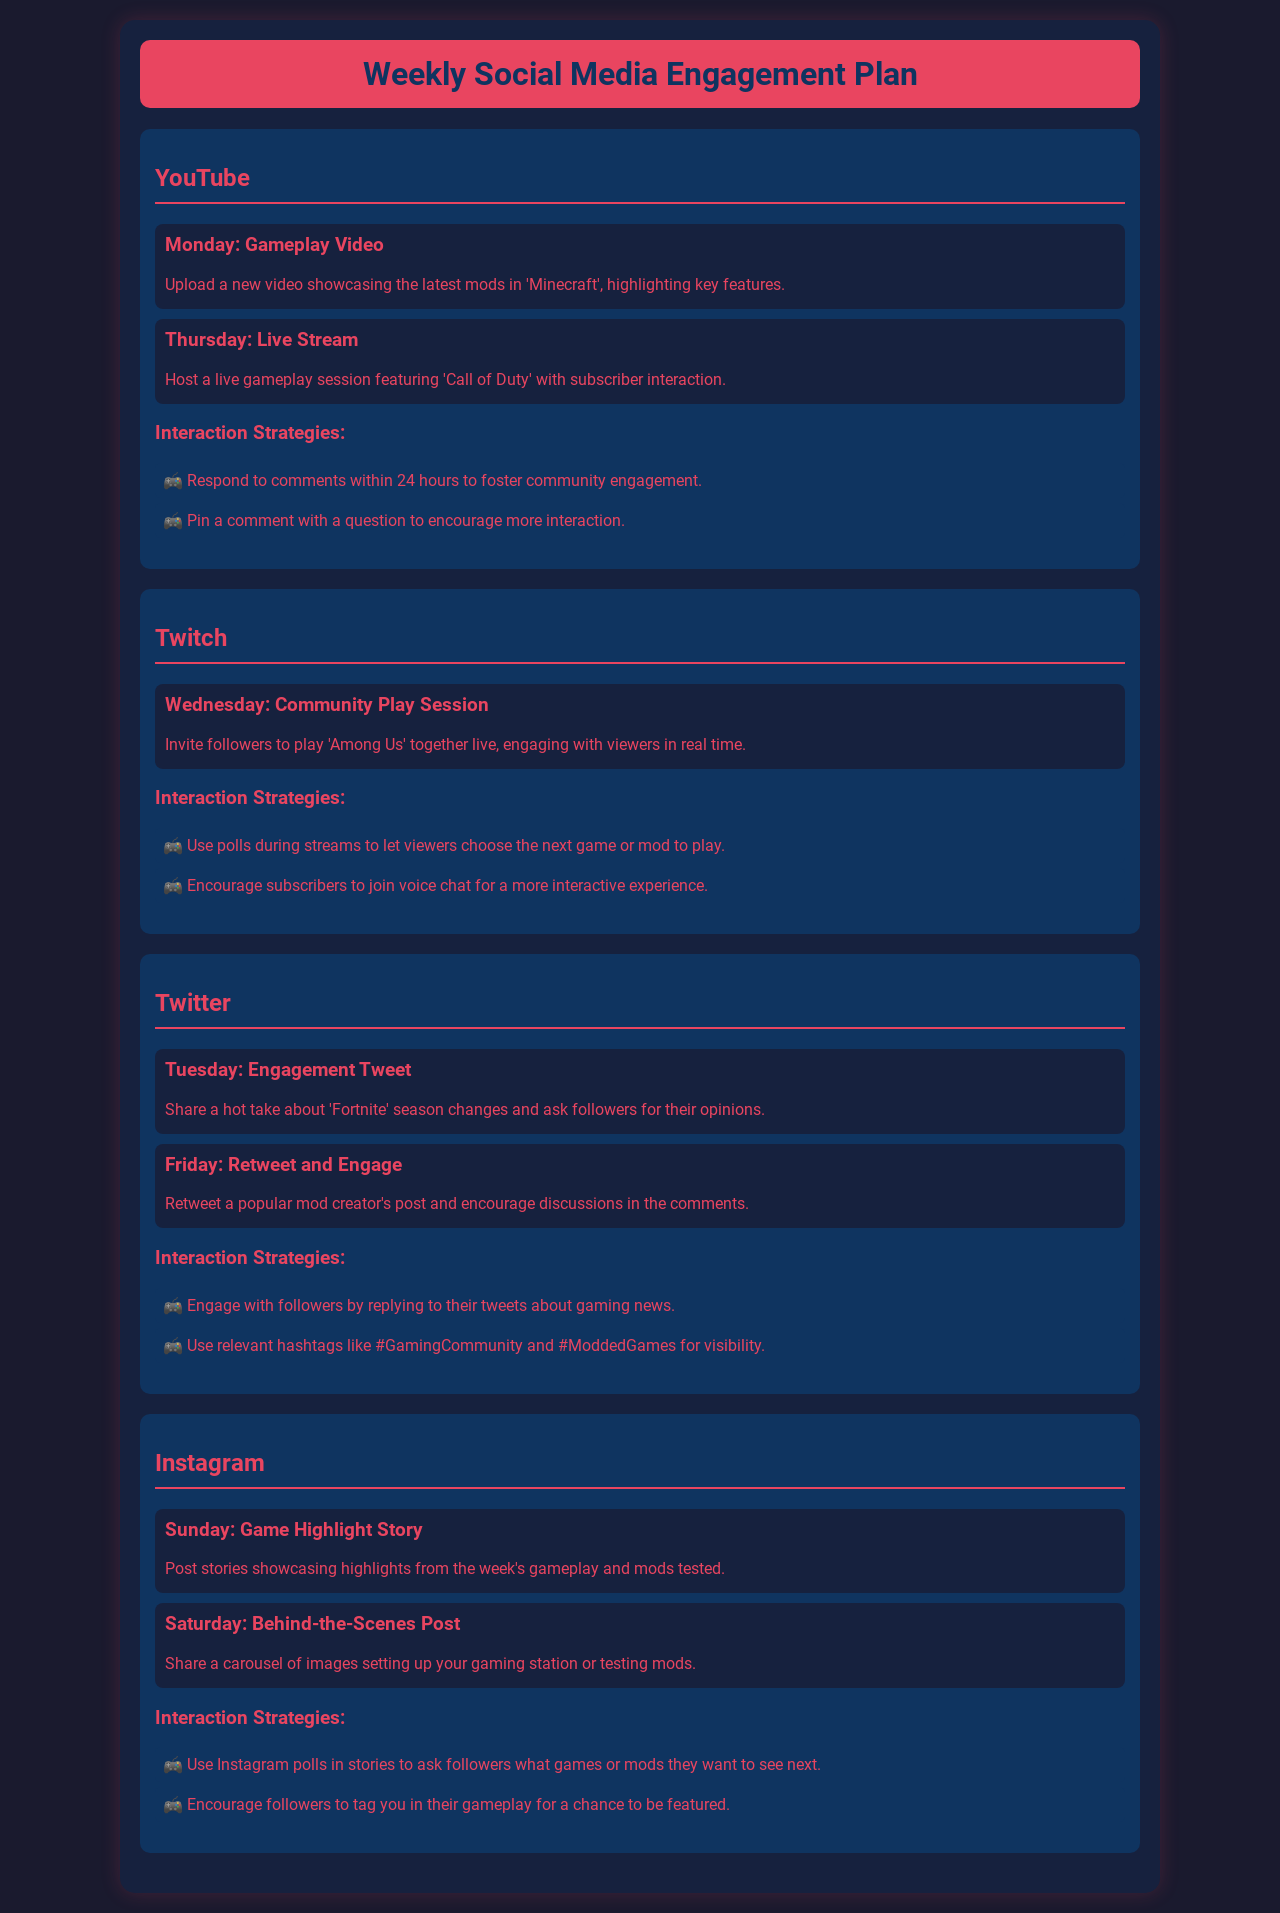What is the post type for Monday on YouTube? The post type for Monday on YouTube is a gameplay video showcasing the latest mods in 'Minecraft'.
Answer: Gameplay Video What game is featured in the Wednesday post on Twitch? The game featured in the Wednesday post on Twitch is 'Among Us'.
Answer: Among Us How often do you respond to comments on YouTube? The document states that you should respond to comments within 24 hours to foster community engagement.
Answer: Within 24 hours What type of interaction strategy is suggested for Instagram? The suggested interaction strategy for Instagram is to use polls in stories to ask followers what games or mods they want to see next.
Answer: Use Instagram polls What is shared on Sunday on Instagram? On Sunday on Instagram, game highlight stories are shared, showcasing highlights from the week's gameplay and mods tested.
Answer: Game Highlight Story How many posts are scheduled for Twitter? The schedule includes two posts for Twitter, one on Tuesday and another on Friday.
Answer: Two posts What day is the live stream scheduled on YouTube? The live stream is scheduled for Thursday on YouTube.
Answer: Thursday What is the primary focus of interaction strategies on Twitch? The primary focus of interaction strategies on Twitch is to use polls during streams to let viewers choose the next game or mod to play.
Answer: Use polls during streams What is the highlight of Friday's post on Twitter? The highlight of Friday's post on Twitter is to retweet a popular mod creator's post and encourage discussions in the comments.
Answer: Retweet and Engage 